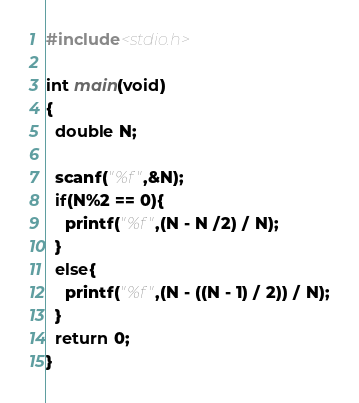Convert code to text. <code><loc_0><loc_0><loc_500><loc_500><_C_>#include<stdio.h>

int main(void)
{
  double N;
  
  scanf("%f",&N);
  if(N%2 == 0){
    printf("%f",(N - N /2) / N);
  }
  else{
    printf("%f",(N - ((N - 1) / 2)) / N);
  }
  return 0;
}</code> 